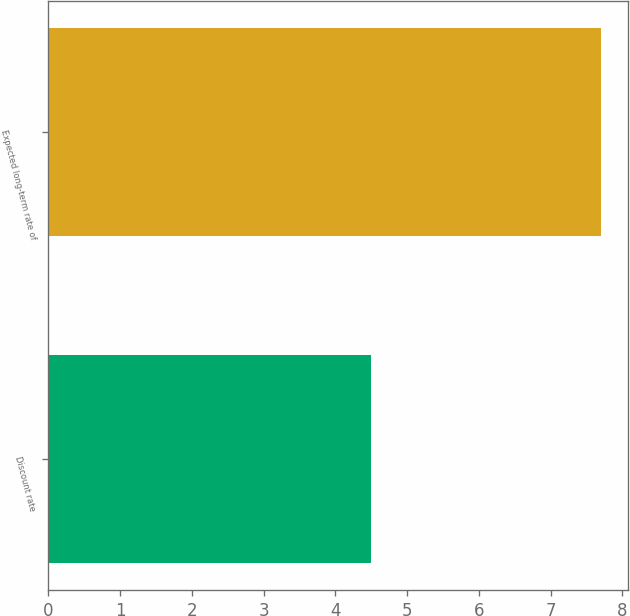Convert chart. <chart><loc_0><loc_0><loc_500><loc_500><bar_chart><fcel>Discount rate<fcel>Expected long-term rate of<nl><fcel>4.5<fcel>7.7<nl></chart> 